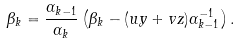Convert formula to latex. <formula><loc_0><loc_0><loc_500><loc_500>\beta _ { k } = \frac { \alpha _ { k - 1 } } { \alpha _ { k } } \left ( \beta _ { k } - ( u y + v z ) \alpha _ { k - 1 } ^ { - 1 } \right ) .</formula> 